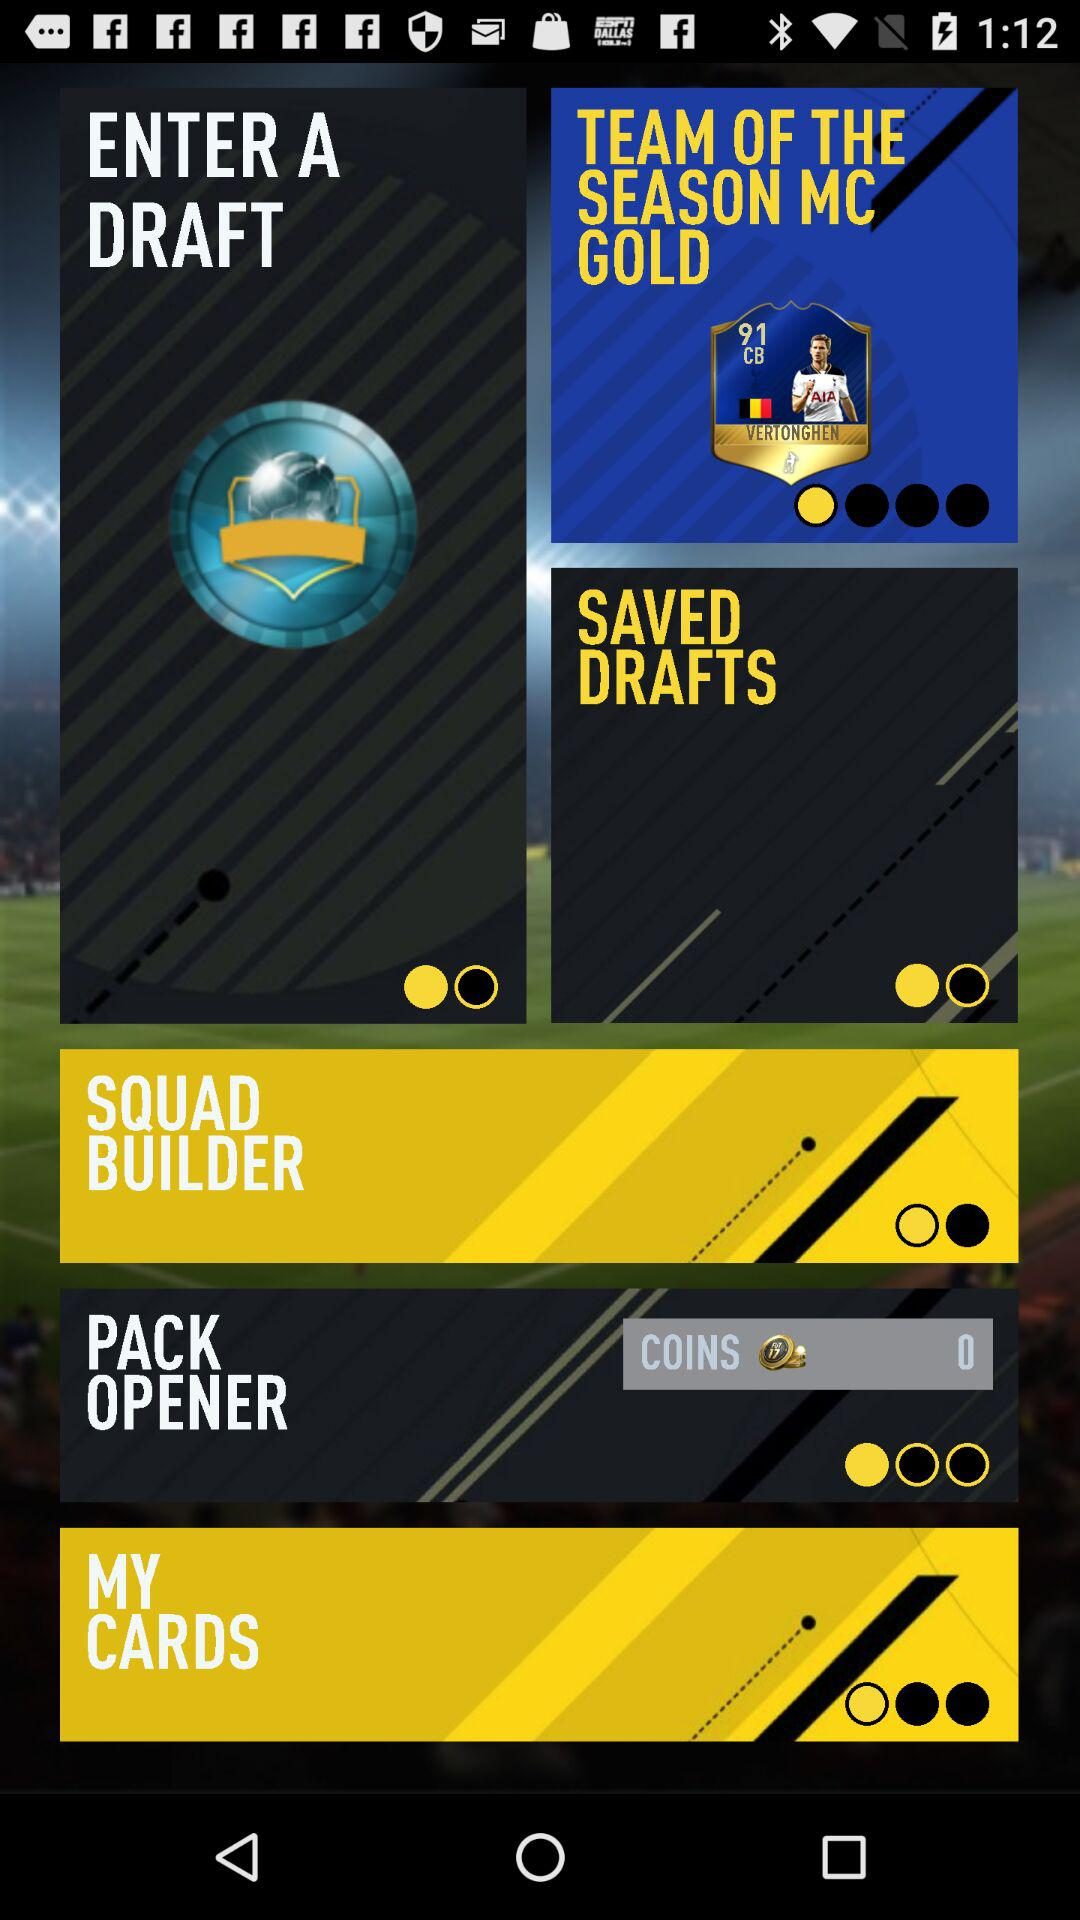What team is the team of the season? The team of the season is "MC GOLD". 